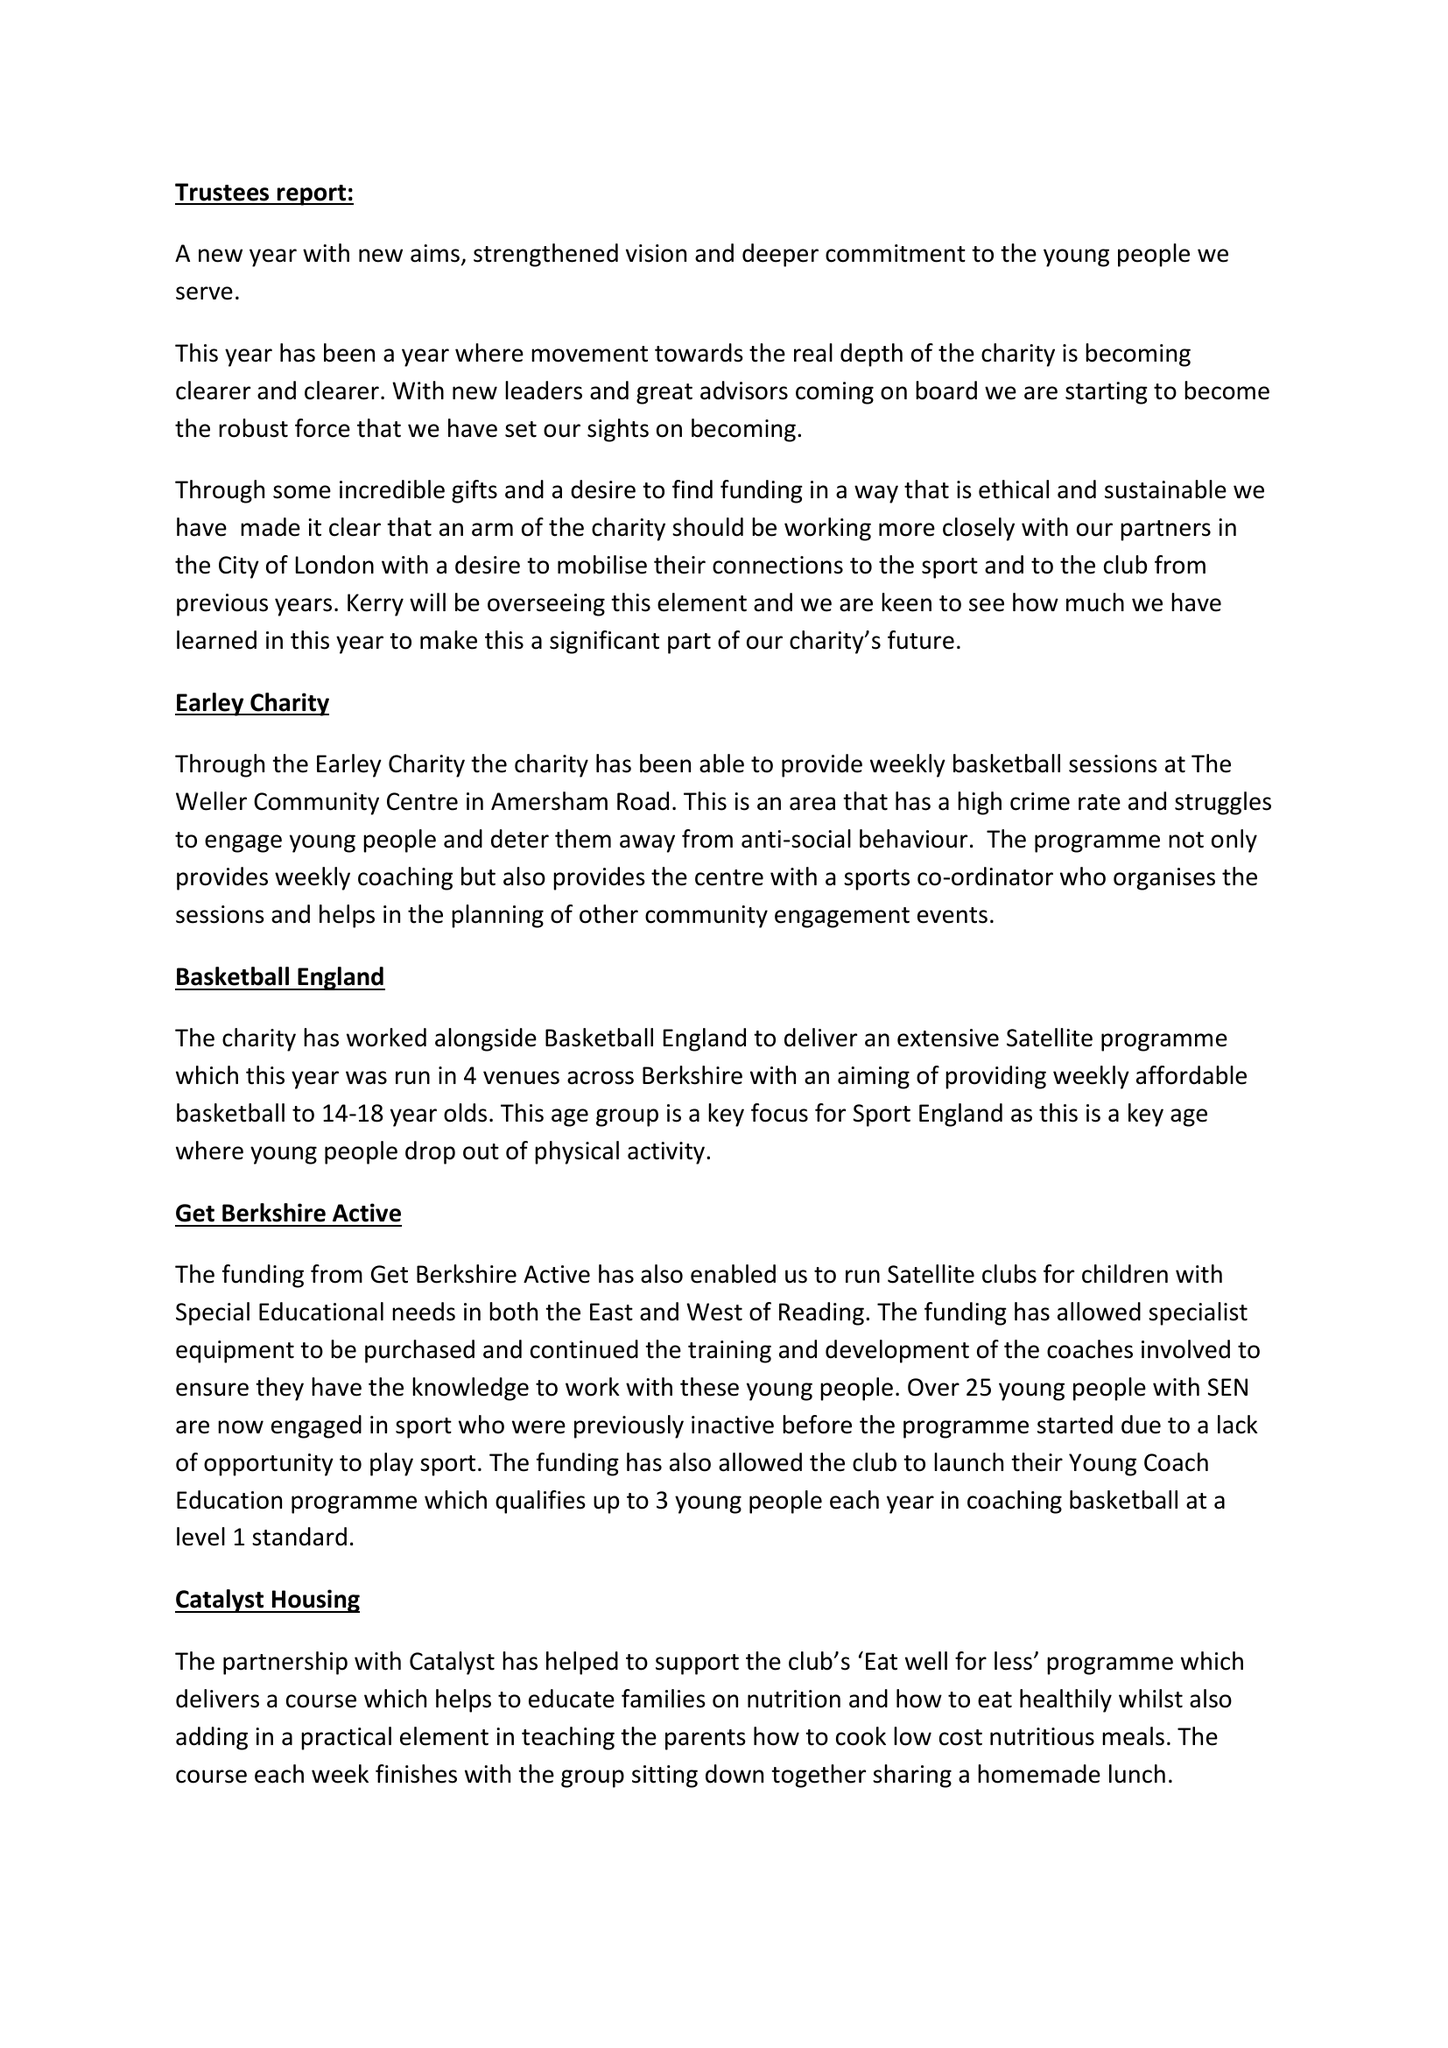What is the value for the report_date?
Answer the question using a single word or phrase. 2018-05-31 